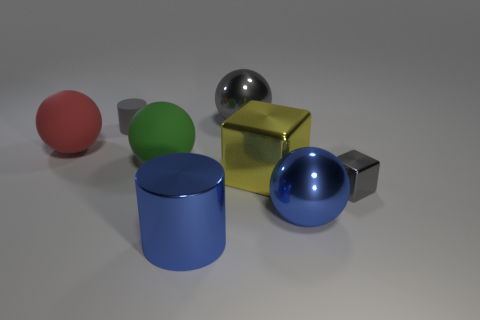If these objects were part of a physics experiment, what properties might be tested? In a physics experiment, properties like the reflectivity and texture of the materials could be examined. Additionally, their shapes lend themselves to studies on equilibrium and the geometric distribution of mass, as well as experiments on how light interacts with different colors and surfaces. 